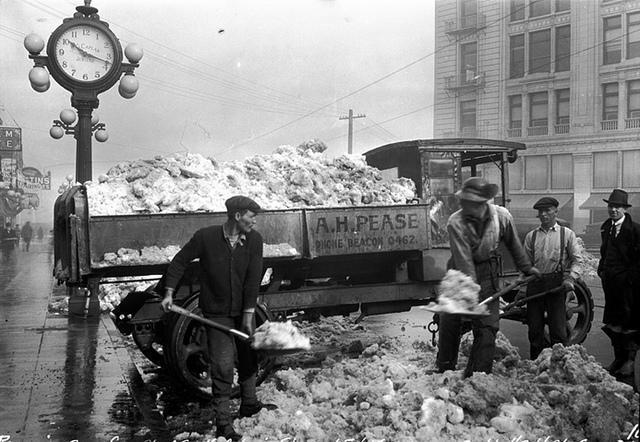What does this vehicle hold in it's rear?
Choose the right answer and clarify with the format: 'Answer: answer
Rationale: rationale.'
Options: Coal, wheat, wood, snow. Answer: snow.
Rationale: The men are shoveling snow into the back of the vehincle. 